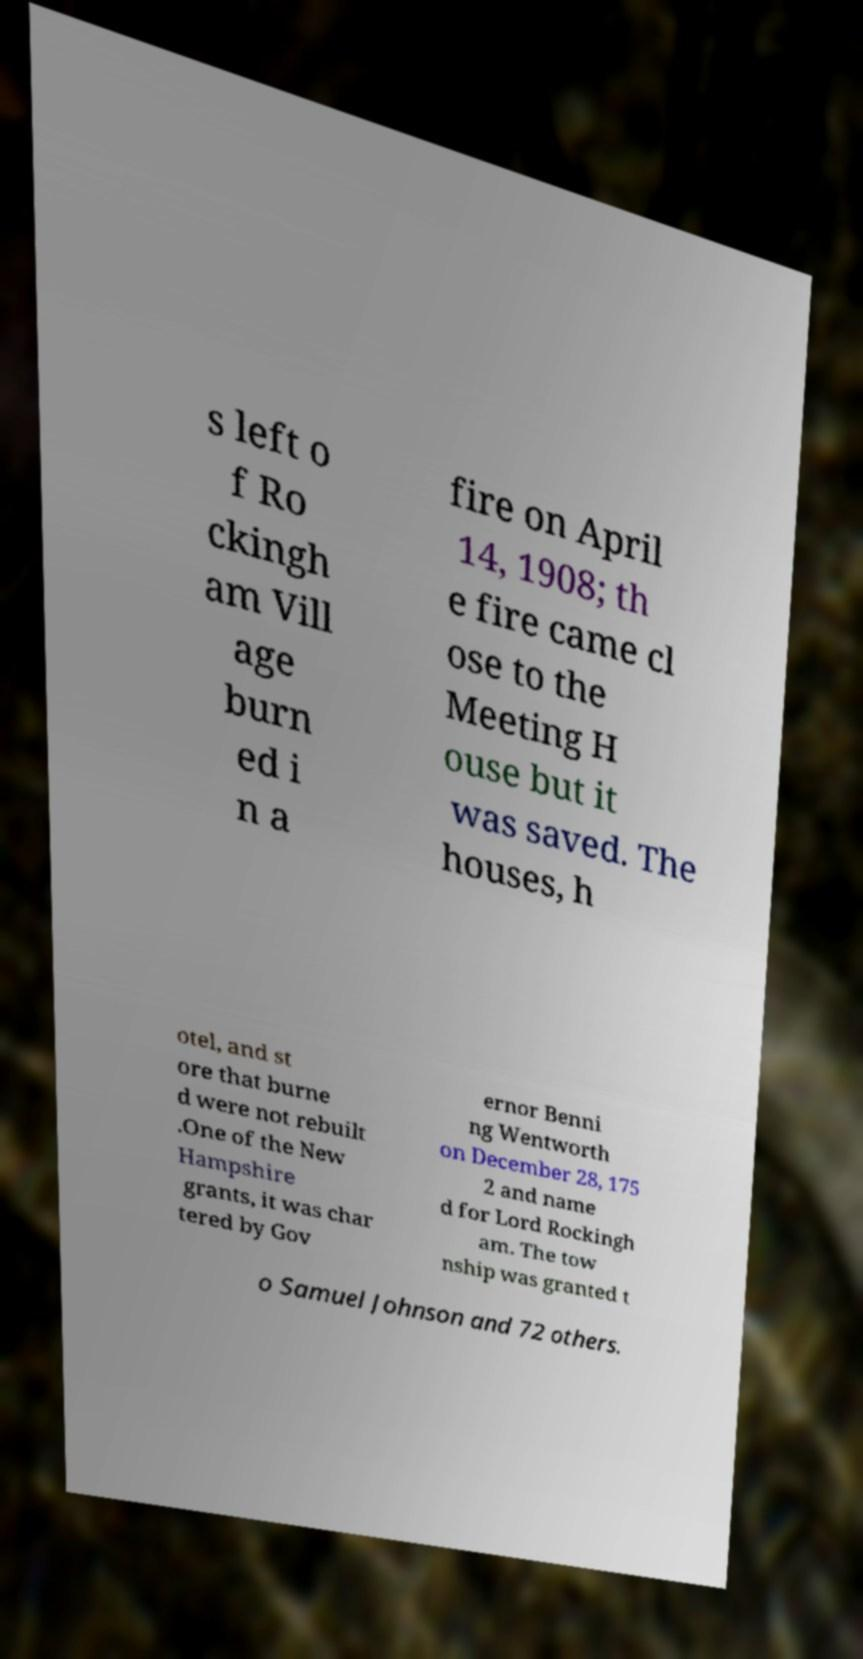Please identify and transcribe the text found in this image. s left o f Ro ckingh am Vill age burn ed i n a fire on April 14, 1908; th e fire came cl ose to the Meeting H ouse but it was saved. The houses, h otel, and st ore that burne d were not rebuilt .One of the New Hampshire grants, it was char tered by Gov ernor Benni ng Wentworth on December 28, 175 2 and name d for Lord Rockingh am. The tow nship was granted t o Samuel Johnson and 72 others. 